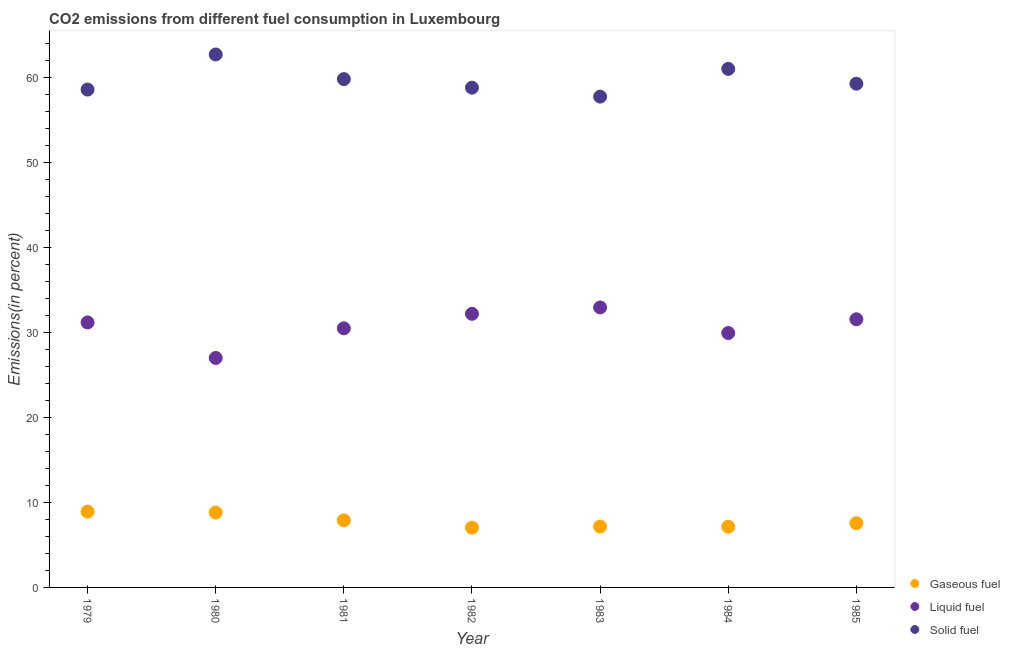Is the number of dotlines equal to the number of legend labels?
Give a very brief answer. Yes. What is the percentage of liquid fuel emission in 1985?
Ensure brevity in your answer.  31.56. Across all years, what is the maximum percentage of solid fuel emission?
Your response must be concise. 62.72. Across all years, what is the minimum percentage of gaseous fuel emission?
Offer a terse response. 7.04. In which year was the percentage of solid fuel emission maximum?
Your answer should be very brief. 1980. What is the total percentage of solid fuel emission in the graph?
Ensure brevity in your answer.  418.02. What is the difference between the percentage of solid fuel emission in 1979 and that in 1985?
Your answer should be compact. -0.69. What is the difference between the percentage of solid fuel emission in 1982 and the percentage of gaseous fuel emission in 1980?
Provide a succinct answer. 50. What is the average percentage of gaseous fuel emission per year?
Provide a short and direct response. 7.79. In the year 1982, what is the difference between the percentage of solid fuel emission and percentage of gaseous fuel emission?
Your answer should be compact. 51.78. What is the ratio of the percentage of solid fuel emission in 1979 to that in 1985?
Ensure brevity in your answer.  0.99. Is the percentage of gaseous fuel emission in 1979 less than that in 1985?
Offer a terse response. No. Is the difference between the percentage of solid fuel emission in 1981 and 1982 greater than the difference between the percentage of gaseous fuel emission in 1981 and 1982?
Keep it short and to the point. Yes. What is the difference between the highest and the second highest percentage of liquid fuel emission?
Offer a terse response. 0.75. What is the difference between the highest and the lowest percentage of gaseous fuel emission?
Offer a terse response. 1.89. Is the sum of the percentage of liquid fuel emission in 1982 and 1983 greater than the maximum percentage of solid fuel emission across all years?
Make the answer very short. Yes. Is it the case that in every year, the sum of the percentage of gaseous fuel emission and percentage of liquid fuel emission is greater than the percentage of solid fuel emission?
Make the answer very short. No. Does the percentage of solid fuel emission monotonically increase over the years?
Provide a short and direct response. No. What is the difference between two consecutive major ticks on the Y-axis?
Your answer should be very brief. 10. Does the graph contain grids?
Provide a succinct answer. No. What is the title of the graph?
Give a very brief answer. CO2 emissions from different fuel consumption in Luxembourg. What is the label or title of the Y-axis?
Your response must be concise. Emissions(in percent). What is the Emissions(in percent) of Gaseous fuel in 1979?
Ensure brevity in your answer.  8.92. What is the Emissions(in percent) of Liquid fuel in 1979?
Provide a short and direct response. 31.19. What is the Emissions(in percent) in Solid fuel in 1979?
Ensure brevity in your answer.  58.59. What is the Emissions(in percent) of Gaseous fuel in 1980?
Your response must be concise. 8.81. What is the Emissions(in percent) of Liquid fuel in 1980?
Give a very brief answer. 27. What is the Emissions(in percent) in Solid fuel in 1980?
Provide a succinct answer. 62.72. What is the Emissions(in percent) in Gaseous fuel in 1981?
Offer a terse response. 7.9. What is the Emissions(in percent) of Liquid fuel in 1981?
Ensure brevity in your answer.  30.49. What is the Emissions(in percent) of Solid fuel in 1981?
Your response must be concise. 59.82. What is the Emissions(in percent) of Gaseous fuel in 1982?
Offer a very short reply. 7.04. What is the Emissions(in percent) in Liquid fuel in 1982?
Offer a terse response. 32.2. What is the Emissions(in percent) in Solid fuel in 1982?
Offer a very short reply. 58.82. What is the Emissions(in percent) of Gaseous fuel in 1983?
Provide a succinct answer. 7.16. What is the Emissions(in percent) of Liquid fuel in 1983?
Your response must be concise. 32.95. What is the Emissions(in percent) in Solid fuel in 1983?
Provide a short and direct response. 57.76. What is the Emissions(in percent) in Gaseous fuel in 1984?
Your answer should be compact. 7.15. What is the Emissions(in percent) of Liquid fuel in 1984?
Your answer should be compact. 29.94. What is the Emissions(in percent) in Solid fuel in 1984?
Your answer should be very brief. 61.03. What is the Emissions(in percent) of Gaseous fuel in 1985?
Your answer should be compact. 7.56. What is the Emissions(in percent) in Liquid fuel in 1985?
Your answer should be very brief. 31.56. What is the Emissions(in percent) in Solid fuel in 1985?
Keep it short and to the point. 59.28. Across all years, what is the maximum Emissions(in percent) of Gaseous fuel?
Offer a very short reply. 8.92. Across all years, what is the maximum Emissions(in percent) of Liquid fuel?
Give a very brief answer. 32.95. Across all years, what is the maximum Emissions(in percent) of Solid fuel?
Make the answer very short. 62.72. Across all years, what is the minimum Emissions(in percent) of Gaseous fuel?
Offer a very short reply. 7.04. Across all years, what is the minimum Emissions(in percent) in Liquid fuel?
Make the answer very short. 27. Across all years, what is the minimum Emissions(in percent) of Solid fuel?
Your answer should be very brief. 57.76. What is the total Emissions(in percent) in Gaseous fuel in the graph?
Keep it short and to the point. 54.54. What is the total Emissions(in percent) of Liquid fuel in the graph?
Your answer should be compact. 215.33. What is the total Emissions(in percent) in Solid fuel in the graph?
Provide a short and direct response. 418.02. What is the difference between the Emissions(in percent) of Gaseous fuel in 1979 and that in 1980?
Keep it short and to the point. 0.11. What is the difference between the Emissions(in percent) in Liquid fuel in 1979 and that in 1980?
Offer a very short reply. 4.18. What is the difference between the Emissions(in percent) in Solid fuel in 1979 and that in 1980?
Keep it short and to the point. -4.13. What is the difference between the Emissions(in percent) of Gaseous fuel in 1979 and that in 1981?
Ensure brevity in your answer.  1.03. What is the difference between the Emissions(in percent) in Liquid fuel in 1979 and that in 1981?
Your answer should be very brief. 0.69. What is the difference between the Emissions(in percent) in Solid fuel in 1979 and that in 1981?
Your answer should be very brief. -1.23. What is the difference between the Emissions(in percent) of Gaseous fuel in 1979 and that in 1982?
Provide a short and direct response. 1.89. What is the difference between the Emissions(in percent) in Liquid fuel in 1979 and that in 1982?
Give a very brief answer. -1.02. What is the difference between the Emissions(in percent) of Solid fuel in 1979 and that in 1982?
Provide a short and direct response. -0.23. What is the difference between the Emissions(in percent) in Gaseous fuel in 1979 and that in 1983?
Your response must be concise. 1.76. What is the difference between the Emissions(in percent) of Liquid fuel in 1979 and that in 1983?
Your response must be concise. -1.76. What is the difference between the Emissions(in percent) of Solid fuel in 1979 and that in 1983?
Offer a terse response. 0.83. What is the difference between the Emissions(in percent) of Gaseous fuel in 1979 and that in 1984?
Provide a short and direct response. 1.78. What is the difference between the Emissions(in percent) in Liquid fuel in 1979 and that in 1984?
Offer a very short reply. 1.25. What is the difference between the Emissions(in percent) in Solid fuel in 1979 and that in 1984?
Your answer should be very brief. -2.44. What is the difference between the Emissions(in percent) in Gaseous fuel in 1979 and that in 1985?
Make the answer very short. 1.36. What is the difference between the Emissions(in percent) in Liquid fuel in 1979 and that in 1985?
Your answer should be very brief. -0.37. What is the difference between the Emissions(in percent) of Solid fuel in 1979 and that in 1985?
Provide a succinct answer. -0.69. What is the difference between the Emissions(in percent) of Gaseous fuel in 1980 and that in 1981?
Make the answer very short. 0.92. What is the difference between the Emissions(in percent) of Liquid fuel in 1980 and that in 1981?
Keep it short and to the point. -3.49. What is the difference between the Emissions(in percent) of Solid fuel in 1980 and that in 1981?
Your answer should be very brief. 2.9. What is the difference between the Emissions(in percent) of Gaseous fuel in 1980 and that in 1982?
Your answer should be very brief. 1.78. What is the difference between the Emissions(in percent) of Liquid fuel in 1980 and that in 1982?
Make the answer very short. -5.2. What is the difference between the Emissions(in percent) of Solid fuel in 1980 and that in 1982?
Ensure brevity in your answer.  3.9. What is the difference between the Emissions(in percent) of Gaseous fuel in 1980 and that in 1983?
Make the answer very short. 1.65. What is the difference between the Emissions(in percent) in Liquid fuel in 1980 and that in 1983?
Provide a short and direct response. -5.95. What is the difference between the Emissions(in percent) in Solid fuel in 1980 and that in 1983?
Provide a short and direct response. 4.96. What is the difference between the Emissions(in percent) of Gaseous fuel in 1980 and that in 1984?
Provide a succinct answer. 1.67. What is the difference between the Emissions(in percent) of Liquid fuel in 1980 and that in 1984?
Your response must be concise. -2.93. What is the difference between the Emissions(in percent) in Solid fuel in 1980 and that in 1984?
Your answer should be compact. 1.69. What is the difference between the Emissions(in percent) in Gaseous fuel in 1980 and that in 1985?
Your answer should be compact. 1.25. What is the difference between the Emissions(in percent) in Liquid fuel in 1980 and that in 1985?
Your response must be concise. -4.56. What is the difference between the Emissions(in percent) in Solid fuel in 1980 and that in 1985?
Your response must be concise. 3.44. What is the difference between the Emissions(in percent) of Gaseous fuel in 1981 and that in 1982?
Offer a very short reply. 0.86. What is the difference between the Emissions(in percent) of Liquid fuel in 1981 and that in 1982?
Your response must be concise. -1.71. What is the difference between the Emissions(in percent) in Solid fuel in 1981 and that in 1982?
Your answer should be very brief. 1. What is the difference between the Emissions(in percent) in Gaseous fuel in 1981 and that in 1983?
Ensure brevity in your answer.  0.73. What is the difference between the Emissions(in percent) of Liquid fuel in 1981 and that in 1983?
Your answer should be very brief. -2.46. What is the difference between the Emissions(in percent) of Solid fuel in 1981 and that in 1983?
Ensure brevity in your answer.  2.06. What is the difference between the Emissions(in percent) in Gaseous fuel in 1981 and that in 1984?
Your response must be concise. 0.75. What is the difference between the Emissions(in percent) of Liquid fuel in 1981 and that in 1984?
Offer a very short reply. 0.56. What is the difference between the Emissions(in percent) of Solid fuel in 1981 and that in 1984?
Offer a very short reply. -1.21. What is the difference between the Emissions(in percent) in Gaseous fuel in 1981 and that in 1985?
Make the answer very short. 0.34. What is the difference between the Emissions(in percent) of Liquid fuel in 1981 and that in 1985?
Your answer should be very brief. -1.07. What is the difference between the Emissions(in percent) of Solid fuel in 1981 and that in 1985?
Your response must be concise. 0.54. What is the difference between the Emissions(in percent) of Gaseous fuel in 1982 and that in 1983?
Keep it short and to the point. -0.13. What is the difference between the Emissions(in percent) in Liquid fuel in 1982 and that in 1983?
Your response must be concise. -0.75. What is the difference between the Emissions(in percent) in Solid fuel in 1982 and that in 1983?
Your answer should be very brief. 1.05. What is the difference between the Emissions(in percent) of Gaseous fuel in 1982 and that in 1984?
Keep it short and to the point. -0.11. What is the difference between the Emissions(in percent) of Liquid fuel in 1982 and that in 1984?
Provide a succinct answer. 2.26. What is the difference between the Emissions(in percent) in Solid fuel in 1982 and that in 1984?
Make the answer very short. -2.21. What is the difference between the Emissions(in percent) of Gaseous fuel in 1982 and that in 1985?
Provide a short and direct response. -0.52. What is the difference between the Emissions(in percent) of Liquid fuel in 1982 and that in 1985?
Keep it short and to the point. 0.64. What is the difference between the Emissions(in percent) in Solid fuel in 1982 and that in 1985?
Offer a very short reply. -0.46. What is the difference between the Emissions(in percent) in Gaseous fuel in 1983 and that in 1984?
Make the answer very short. 0.02. What is the difference between the Emissions(in percent) in Liquid fuel in 1983 and that in 1984?
Your answer should be very brief. 3.01. What is the difference between the Emissions(in percent) of Solid fuel in 1983 and that in 1984?
Offer a terse response. -3.26. What is the difference between the Emissions(in percent) of Gaseous fuel in 1983 and that in 1985?
Keep it short and to the point. -0.4. What is the difference between the Emissions(in percent) of Liquid fuel in 1983 and that in 1985?
Make the answer very short. 1.39. What is the difference between the Emissions(in percent) in Solid fuel in 1983 and that in 1985?
Provide a succinct answer. -1.52. What is the difference between the Emissions(in percent) in Gaseous fuel in 1984 and that in 1985?
Offer a very short reply. -0.41. What is the difference between the Emissions(in percent) of Liquid fuel in 1984 and that in 1985?
Make the answer very short. -1.62. What is the difference between the Emissions(in percent) in Solid fuel in 1984 and that in 1985?
Keep it short and to the point. 1.75. What is the difference between the Emissions(in percent) in Gaseous fuel in 1979 and the Emissions(in percent) in Liquid fuel in 1980?
Give a very brief answer. -18.08. What is the difference between the Emissions(in percent) in Gaseous fuel in 1979 and the Emissions(in percent) in Solid fuel in 1980?
Offer a very short reply. -53.8. What is the difference between the Emissions(in percent) of Liquid fuel in 1979 and the Emissions(in percent) of Solid fuel in 1980?
Offer a very short reply. -31.53. What is the difference between the Emissions(in percent) of Gaseous fuel in 1979 and the Emissions(in percent) of Liquid fuel in 1981?
Offer a terse response. -21.57. What is the difference between the Emissions(in percent) in Gaseous fuel in 1979 and the Emissions(in percent) in Solid fuel in 1981?
Your answer should be very brief. -50.9. What is the difference between the Emissions(in percent) in Liquid fuel in 1979 and the Emissions(in percent) in Solid fuel in 1981?
Give a very brief answer. -28.64. What is the difference between the Emissions(in percent) in Gaseous fuel in 1979 and the Emissions(in percent) in Liquid fuel in 1982?
Your response must be concise. -23.28. What is the difference between the Emissions(in percent) in Gaseous fuel in 1979 and the Emissions(in percent) in Solid fuel in 1982?
Make the answer very short. -49.89. What is the difference between the Emissions(in percent) of Liquid fuel in 1979 and the Emissions(in percent) of Solid fuel in 1982?
Offer a very short reply. -27.63. What is the difference between the Emissions(in percent) of Gaseous fuel in 1979 and the Emissions(in percent) of Liquid fuel in 1983?
Give a very brief answer. -24.03. What is the difference between the Emissions(in percent) in Gaseous fuel in 1979 and the Emissions(in percent) in Solid fuel in 1983?
Provide a short and direct response. -48.84. What is the difference between the Emissions(in percent) of Liquid fuel in 1979 and the Emissions(in percent) of Solid fuel in 1983?
Ensure brevity in your answer.  -26.58. What is the difference between the Emissions(in percent) of Gaseous fuel in 1979 and the Emissions(in percent) of Liquid fuel in 1984?
Provide a succinct answer. -21.02. What is the difference between the Emissions(in percent) of Gaseous fuel in 1979 and the Emissions(in percent) of Solid fuel in 1984?
Offer a terse response. -52.1. What is the difference between the Emissions(in percent) of Liquid fuel in 1979 and the Emissions(in percent) of Solid fuel in 1984?
Provide a succinct answer. -29.84. What is the difference between the Emissions(in percent) of Gaseous fuel in 1979 and the Emissions(in percent) of Liquid fuel in 1985?
Keep it short and to the point. -22.64. What is the difference between the Emissions(in percent) in Gaseous fuel in 1979 and the Emissions(in percent) in Solid fuel in 1985?
Your answer should be compact. -50.36. What is the difference between the Emissions(in percent) in Liquid fuel in 1979 and the Emissions(in percent) in Solid fuel in 1985?
Keep it short and to the point. -28.09. What is the difference between the Emissions(in percent) in Gaseous fuel in 1980 and the Emissions(in percent) in Liquid fuel in 1981?
Your answer should be compact. -21.68. What is the difference between the Emissions(in percent) in Gaseous fuel in 1980 and the Emissions(in percent) in Solid fuel in 1981?
Provide a short and direct response. -51.01. What is the difference between the Emissions(in percent) of Liquid fuel in 1980 and the Emissions(in percent) of Solid fuel in 1981?
Provide a short and direct response. -32.82. What is the difference between the Emissions(in percent) of Gaseous fuel in 1980 and the Emissions(in percent) of Liquid fuel in 1982?
Offer a very short reply. -23.39. What is the difference between the Emissions(in percent) of Gaseous fuel in 1980 and the Emissions(in percent) of Solid fuel in 1982?
Keep it short and to the point. -50. What is the difference between the Emissions(in percent) of Liquid fuel in 1980 and the Emissions(in percent) of Solid fuel in 1982?
Offer a very short reply. -31.81. What is the difference between the Emissions(in percent) of Gaseous fuel in 1980 and the Emissions(in percent) of Liquid fuel in 1983?
Provide a short and direct response. -24.14. What is the difference between the Emissions(in percent) of Gaseous fuel in 1980 and the Emissions(in percent) of Solid fuel in 1983?
Your answer should be very brief. -48.95. What is the difference between the Emissions(in percent) of Liquid fuel in 1980 and the Emissions(in percent) of Solid fuel in 1983?
Your answer should be very brief. -30.76. What is the difference between the Emissions(in percent) in Gaseous fuel in 1980 and the Emissions(in percent) in Liquid fuel in 1984?
Make the answer very short. -21.13. What is the difference between the Emissions(in percent) of Gaseous fuel in 1980 and the Emissions(in percent) of Solid fuel in 1984?
Make the answer very short. -52.21. What is the difference between the Emissions(in percent) in Liquid fuel in 1980 and the Emissions(in percent) in Solid fuel in 1984?
Provide a succinct answer. -34.02. What is the difference between the Emissions(in percent) in Gaseous fuel in 1980 and the Emissions(in percent) in Liquid fuel in 1985?
Ensure brevity in your answer.  -22.75. What is the difference between the Emissions(in percent) in Gaseous fuel in 1980 and the Emissions(in percent) in Solid fuel in 1985?
Your answer should be compact. -50.47. What is the difference between the Emissions(in percent) of Liquid fuel in 1980 and the Emissions(in percent) of Solid fuel in 1985?
Offer a terse response. -32.28. What is the difference between the Emissions(in percent) in Gaseous fuel in 1981 and the Emissions(in percent) in Liquid fuel in 1982?
Offer a very short reply. -24.31. What is the difference between the Emissions(in percent) in Gaseous fuel in 1981 and the Emissions(in percent) in Solid fuel in 1982?
Keep it short and to the point. -50.92. What is the difference between the Emissions(in percent) in Liquid fuel in 1981 and the Emissions(in percent) in Solid fuel in 1982?
Your response must be concise. -28.32. What is the difference between the Emissions(in percent) of Gaseous fuel in 1981 and the Emissions(in percent) of Liquid fuel in 1983?
Your answer should be compact. -25.05. What is the difference between the Emissions(in percent) of Gaseous fuel in 1981 and the Emissions(in percent) of Solid fuel in 1983?
Provide a short and direct response. -49.87. What is the difference between the Emissions(in percent) in Liquid fuel in 1981 and the Emissions(in percent) in Solid fuel in 1983?
Make the answer very short. -27.27. What is the difference between the Emissions(in percent) in Gaseous fuel in 1981 and the Emissions(in percent) in Liquid fuel in 1984?
Ensure brevity in your answer.  -22.04. What is the difference between the Emissions(in percent) in Gaseous fuel in 1981 and the Emissions(in percent) in Solid fuel in 1984?
Give a very brief answer. -53.13. What is the difference between the Emissions(in percent) in Liquid fuel in 1981 and the Emissions(in percent) in Solid fuel in 1984?
Offer a very short reply. -30.53. What is the difference between the Emissions(in percent) of Gaseous fuel in 1981 and the Emissions(in percent) of Liquid fuel in 1985?
Offer a very short reply. -23.66. What is the difference between the Emissions(in percent) of Gaseous fuel in 1981 and the Emissions(in percent) of Solid fuel in 1985?
Ensure brevity in your answer.  -51.38. What is the difference between the Emissions(in percent) in Liquid fuel in 1981 and the Emissions(in percent) in Solid fuel in 1985?
Your answer should be compact. -28.79. What is the difference between the Emissions(in percent) of Gaseous fuel in 1982 and the Emissions(in percent) of Liquid fuel in 1983?
Offer a terse response. -25.91. What is the difference between the Emissions(in percent) in Gaseous fuel in 1982 and the Emissions(in percent) in Solid fuel in 1983?
Give a very brief answer. -50.73. What is the difference between the Emissions(in percent) in Liquid fuel in 1982 and the Emissions(in percent) in Solid fuel in 1983?
Ensure brevity in your answer.  -25.56. What is the difference between the Emissions(in percent) of Gaseous fuel in 1982 and the Emissions(in percent) of Liquid fuel in 1984?
Offer a terse response. -22.9. What is the difference between the Emissions(in percent) of Gaseous fuel in 1982 and the Emissions(in percent) of Solid fuel in 1984?
Make the answer very short. -53.99. What is the difference between the Emissions(in percent) in Liquid fuel in 1982 and the Emissions(in percent) in Solid fuel in 1984?
Your answer should be very brief. -28.82. What is the difference between the Emissions(in percent) in Gaseous fuel in 1982 and the Emissions(in percent) in Liquid fuel in 1985?
Provide a short and direct response. -24.52. What is the difference between the Emissions(in percent) of Gaseous fuel in 1982 and the Emissions(in percent) of Solid fuel in 1985?
Offer a terse response. -52.24. What is the difference between the Emissions(in percent) in Liquid fuel in 1982 and the Emissions(in percent) in Solid fuel in 1985?
Give a very brief answer. -27.08. What is the difference between the Emissions(in percent) of Gaseous fuel in 1983 and the Emissions(in percent) of Liquid fuel in 1984?
Provide a short and direct response. -22.77. What is the difference between the Emissions(in percent) in Gaseous fuel in 1983 and the Emissions(in percent) in Solid fuel in 1984?
Offer a very short reply. -53.86. What is the difference between the Emissions(in percent) of Liquid fuel in 1983 and the Emissions(in percent) of Solid fuel in 1984?
Make the answer very short. -28.08. What is the difference between the Emissions(in percent) of Gaseous fuel in 1983 and the Emissions(in percent) of Liquid fuel in 1985?
Ensure brevity in your answer.  -24.39. What is the difference between the Emissions(in percent) of Gaseous fuel in 1983 and the Emissions(in percent) of Solid fuel in 1985?
Your answer should be very brief. -52.12. What is the difference between the Emissions(in percent) of Liquid fuel in 1983 and the Emissions(in percent) of Solid fuel in 1985?
Ensure brevity in your answer.  -26.33. What is the difference between the Emissions(in percent) of Gaseous fuel in 1984 and the Emissions(in percent) of Liquid fuel in 1985?
Give a very brief answer. -24.41. What is the difference between the Emissions(in percent) in Gaseous fuel in 1984 and the Emissions(in percent) in Solid fuel in 1985?
Ensure brevity in your answer.  -52.13. What is the difference between the Emissions(in percent) of Liquid fuel in 1984 and the Emissions(in percent) of Solid fuel in 1985?
Your answer should be very brief. -29.34. What is the average Emissions(in percent) of Gaseous fuel per year?
Your answer should be compact. 7.79. What is the average Emissions(in percent) of Liquid fuel per year?
Ensure brevity in your answer.  30.76. What is the average Emissions(in percent) of Solid fuel per year?
Offer a terse response. 59.72. In the year 1979, what is the difference between the Emissions(in percent) in Gaseous fuel and Emissions(in percent) in Liquid fuel?
Ensure brevity in your answer.  -22.26. In the year 1979, what is the difference between the Emissions(in percent) in Gaseous fuel and Emissions(in percent) in Solid fuel?
Offer a terse response. -49.67. In the year 1979, what is the difference between the Emissions(in percent) in Liquid fuel and Emissions(in percent) in Solid fuel?
Offer a very short reply. -27.4. In the year 1980, what is the difference between the Emissions(in percent) in Gaseous fuel and Emissions(in percent) in Liquid fuel?
Your response must be concise. -18.19. In the year 1980, what is the difference between the Emissions(in percent) of Gaseous fuel and Emissions(in percent) of Solid fuel?
Make the answer very short. -53.91. In the year 1980, what is the difference between the Emissions(in percent) in Liquid fuel and Emissions(in percent) in Solid fuel?
Offer a terse response. -35.72. In the year 1981, what is the difference between the Emissions(in percent) of Gaseous fuel and Emissions(in percent) of Liquid fuel?
Offer a terse response. -22.6. In the year 1981, what is the difference between the Emissions(in percent) of Gaseous fuel and Emissions(in percent) of Solid fuel?
Make the answer very short. -51.93. In the year 1981, what is the difference between the Emissions(in percent) of Liquid fuel and Emissions(in percent) of Solid fuel?
Offer a very short reply. -29.33. In the year 1982, what is the difference between the Emissions(in percent) in Gaseous fuel and Emissions(in percent) in Liquid fuel?
Keep it short and to the point. -25.17. In the year 1982, what is the difference between the Emissions(in percent) in Gaseous fuel and Emissions(in percent) in Solid fuel?
Make the answer very short. -51.78. In the year 1982, what is the difference between the Emissions(in percent) of Liquid fuel and Emissions(in percent) of Solid fuel?
Your answer should be compact. -26.61. In the year 1983, what is the difference between the Emissions(in percent) in Gaseous fuel and Emissions(in percent) in Liquid fuel?
Provide a short and direct response. -25.79. In the year 1983, what is the difference between the Emissions(in percent) of Gaseous fuel and Emissions(in percent) of Solid fuel?
Keep it short and to the point. -50.6. In the year 1983, what is the difference between the Emissions(in percent) in Liquid fuel and Emissions(in percent) in Solid fuel?
Provide a short and direct response. -24.81. In the year 1984, what is the difference between the Emissions(in percent) of Gaseous fuel and Emissions(in percent) of Liquid fuel?
Make the answer very short. -22.79. In the year 1984, what is the difference between the Emissions(in percent) in Gaseous fuel and Emissions(in percent) in Solid fuel?
Provide a succinct answer. -53.88. In the year 1984, what is the difference between the Emissions(in percent) in Liquid fuel and Emissions(in percent) in Solid fuel?
Give a very brief answer. -31.09. In the year 1985, what is the difference between the Emissions(in percent) in Gaseous fuel and Emissions(in percent) in Solid fuel?
Offer a very short reply. -51.72. In the year 1985, what is the difference between the Emissions(in percent) in Liquid fuel and Emissions(in percent) in Solid fuel?
Your answer should be compact. -27.72. What is the ratio of the Emissions(in percent) in Gaseous fuel in 1979 to that in 1980?
Offer a very short reply. 1.01. What is the ratio of the Emissions(in percent) in Liquid fuel in 1979 to that in 1980?
Provide a short and direct response. 1.15. What is the ratio of the Emissions(in percent) of Solid fuel in 1979 to that in 1980?
Your response must be concise. 0.93. What is the ratio of the Emissions(in percent) in Gaseous fuel in 1979 to that in 1981?
Keep it short and to the point. 1.13. What is the ratio of the Emissions(in percent) of Liquid fuel in 1979 to that in 1981?
Offer a terse response. 1.02. What is the ratio of the Emissions(in percent) in Solid fuel in 1979 to that in 1981?
Provide a succinct answer. 0.98. What is the ratio of the Emissions(in percent) of Gaseous fuel in 1979 to that in 1982?
Your response must be concise. 1.27. What is the ratio of the Emissions(in percent) in Liquid fuel in 1979 to that in 1982?
Provide a succinct answer. 0.97. What is the ratio of the Emissions(in percent) in Gaseous fuel in 1979 to that in 1983?
Offer a terse response. 1.25. What is the ratio of the Emissions(in percent) in Liquid fuel in 1979 to that in 1983?
Provide a succinct answer. 0.95. What is the ratio of the Emissions(in percent) of Solid fuel in 1979 to that in 1983?
Ensure brevity in your answer.  1.01. What is the ratio of the Emissions(in percent) of Gaseous fuel in 1979 to that in 1984?
Keep it short and to the point. 1.25. What is the ratio of the Emissions(in percent) of Liquid fuel in 1979 to that in 1984?
Offer a terse response. 1.04. What is the ratio of the Emissions(in percent) in Solid fuel in 1979 to that in 1984?
Ensure brevity in your answer.  0.96. What is the ratio of the Emissions(in percent) of Gaseous fuel in 1979 to that in 1985?
Offer a terse response. 1.18. What is the ratio of the Emissions(in percent) of Liquid fuel in 1979 to that in 1985?
Keep it short and to the point. 0.99. What is the ratio of the Emissions(in percent) of Solid fuel in 1979 to that in 1985?
Your answer should be compact. 0.99. What is the ratio of the Emissions(in percent) in Gaseous fuel in 1980 to that in 1981?
Your response must be concise. 1.12. What is the ratio of the Emissions(in percent) in Liquid fuel in 1980 to that in 1981?
Give a very brief answer. 0.89. What is the ratio of the Emissions(in percent) of Solid fuel in 1980 to that in 1981?
Your answer should be very brief. 1.05. What is the ratio of the Emissions(in percent) of Gaseous fuel in 1980 to that in 1982?
Give a very brief answer. 1.25. What is the ratio of the Emissions(in percent) of Liquid fuel in 1980 to that in 1982?
Ensure brevity in your answer.  0.84. What is the ratio of the Emissions(in percent) of Solid fuel in 1980 to that in 1982?
Your answer should be compact. 1.07. What is the ratio of the Emissions(in percent) of Gaseous fuel in 1980 to that in 1983?
Keep it short and to the point. 1.23. What is the ratio of the Emissions(in percent) of Liquid fuel in 1980 to that in 1983?
Make the answer very short. 0.82. What is the ratio of the Emissions(in percent) in Solid fuel in 1980 to that in 1983?
Make the answer very short. 1.09. What is the ratio of the Emissions(in percent) of Gaseous fuel in 1980 to that in 1984?
Your answer should be very brief. 1.23. What is the ratio of the Emissions(in percent) in Liquid fuel in 1980 to that in 1984?
Offer a very short reply. 0.9. What is the ratio of the Emissions(in percent) of Solid fuel in 1980 to that in 1984?
Provide a short and direct response. 1.03. What is the ratio of the Emissions(in percent) of Gaseous fuel in 1980 to that in 1985?
Your answer should be very brief. 1.17. What is the ratio of the Emissions(in percent) in Liquid fuel in 1980 to that in 1985?
Give a very brief answer. 0.86. What is the ratio of the Emissions(in percent) in Solid fuel in 1980 to that in 1985?
Your response must be concise. 1.06. What is the ratio of the Emissions(in percent) of Gaseous fuel in 1981 to that in 1982?
Provide a succinct answer. 1.12. What is the ratio of the Emissions(in percent) of Liquid fuel in 1981 to that in 1982?
Provide a short and direct response. 0.95. What is the ratio of the Emissions(in percent) of Solid fuel in 1981 to that in 1982?
Keep it short and to the point. 1.02. What is the ratio of the Emissions(in percent) in Gaseous fuel in 1981 to that in 1983?
Your answer should be very brief. 1.1. What is the ratio of the Emissions(in percent) of Liquid fuel in 1981 to that in 1983?
Offer a terse response. 0.93. What is the ratio of the Emissions(in percent) of Solid fuel in 1981 to that in 1983?
Your answer should be very brief. 1.04. What is the ratio of the Emissions(in percent) of Gaseous fuel in 1981 to that in 1984?
Your answer should be compact. 1.1. What is the ratio of the Emissions(in percent) in Liquid fuel in 1981 to that in 1984?
Provide a short and direct response. 1.02. What is the ratio of the Emissions(in percent) in Solid fuel in 1981 to that in 1984?
Ensure brevity in your answer.  0.98. What is the ratio of the Emissions(in percent) of Gaseous fuel in 1981 to that in 1985?
Your response must be concise. 1.04. What is the ratio of the Emissions(in percent) of Liquid fuel in 1981 to that in 1985?
Your answer should be compact. 0.97. What is the ratio of the Emissions(in percent) in Solid fuel in 1981 to that in 1985?
Provide a succinct answer. 1.01. What is the ratio of the Emissions(in percent) of Gaseous fuel in 1982 to that in 1983?
Your answer should be very brief. 0.98. What is the ratio of the Emissions(in percent) of Liquid fuel in 1982 to that in 1983?
Your answer should be very brief. 0.98. What is the ratio of the Emissions(in percent) in Solid fuel in 1982 to that in 1983?
Give a very brief answer. 1.02. What is the ratio of the Emissions(in percent) of Gaseous fuel in 1982 to that in 1984?
Provide a succinct answer. 0.98. What is the ratio of the Emissions(in percent) of Liquid fuel in 1982 to that in 1984?
Offer a terse response. 1.08. What is the ratio of the Emissions(in percent) in Solid fuel in 1982 to that in 1984?
Keep it short and to the point. 0.96. What is the ratio of the Emissions(in percent) of Gaseous fuel in 1982 to that in 1985?
Provide a short and direct response. 0.93. What is the ratio of the Emissions(in percent) of Liquid fuel in 1982 to that in 1985?
Offer a very short reply. 1.02. What is the ratio of the Emissions(in percent) in Solid fuel in 1982 to that in 1985?
Your answer should be compact. 0.99. What is the ratio of the Emissions(in percent) in Liquid fuel in 1983 to that in 1984?
Keep it short and to the point. 1.1. What is the ratio of the Emissions(in percent) of Solid fuel in 1983 to that in 1984?
Keep it short and to the point. 0.95. What is the ratio of the Emissions(in percent) of Gaseous fuel in 1983 to that in 1985?
Your answer should be compact. 0.95. What is the ratio of the Emissions(in percent) of Liquid fuel in 1983 to that in 1985?
Give a very brief answer. 1.04. What is the ratio of the Emissions(in percent) in Solid fuel in 1983 to that in 1985?
Your response must be concise. 0.97. What is the ratio of the Emissions(in percent) of Gaseous fuel in 1984 to that in 1985?
Your answer should be compact. 0.95. What is the ratio of the Emissions(in percent) in Liquid fuel in 1984 to that in 1985?
Give a very brief answer. 0.95. What is the ratio of the Emissions(in percent) of Solid fuel in 1984 to that in 1985?
Keep it short and to the point. 1.03. What is the difference between the highest and the second highest Emissions(in percent) in Gaseous fuel?
Provide a short and direct response. 0.11. What is the difference between the highest and the second highest Emissions(in percent) of Liquid fuel?
Your response must be concise. 0.75. What is the difference between the highest and the second highest Emissions(in percent) of Solid fuel?
Make the answer very short. 1.69. What is the difference between the highest and the lowest Emissions(in percent) in Gaseous fuel?
Provide a succinct answer. 1.89. What is the difference between the highest and the lowest Emissions(in percent) of Liquid fuel?
Make the answer very short. 5.95. What is the difference between the highest and the lowest Emissions(in percent) in Solid fuel?
Provide a succinct answer. 4.96. 